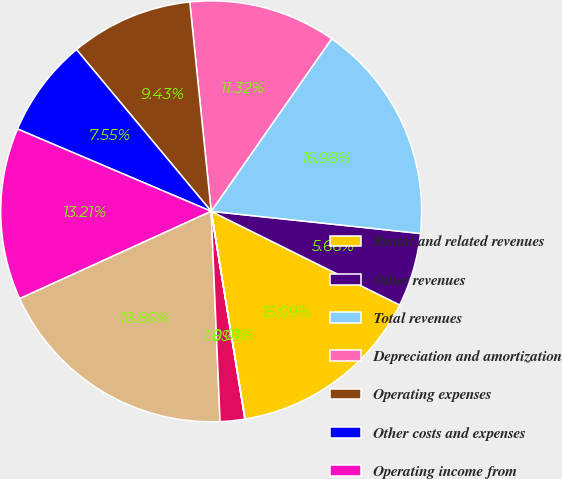Convert chart. <chart><loc_0><loc_0><loc_500><loc_500><pie_chart><fcel>Rental and related revenues<fcel>Other revenues<fcel>Total revenues<fcel>Depreciation and amortization<fcel>Operating expenses<fcel>Other costs and expenses<fcel>Operating income from<fcel>Gains on sales of real estate<fcel>Number of properties held for<fcel>Number of properties sold<nl><fcel>15.09%<fcel>5.66%<fcel>16.98%<fcel>11.32%<fcel>9.43%<fcel>7.55%<fcel>13.21%<fcel>18.86%<fcel>1.89%<fcel>0.01%<nl></chart> 